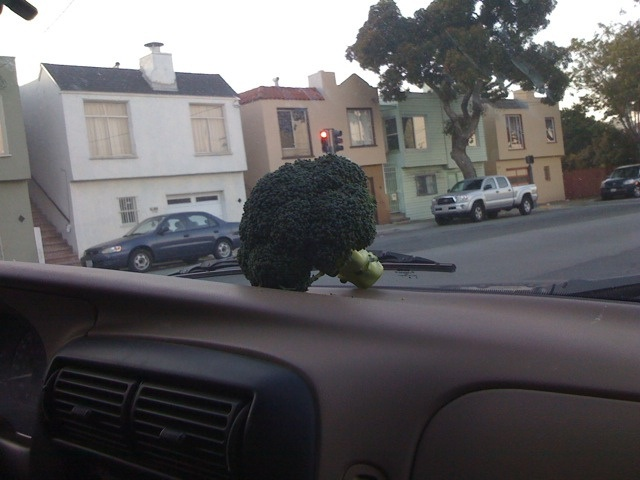Describe the objects in this image and their specific colors. I can see broccoli in black, gray, darkgray, and purple tones, car in black, gray, and darkgray tones, truck in black, gray, and darkgray tones, car in black, gray, and darkgray tones, and traffic light in black and gray tones in this image. 